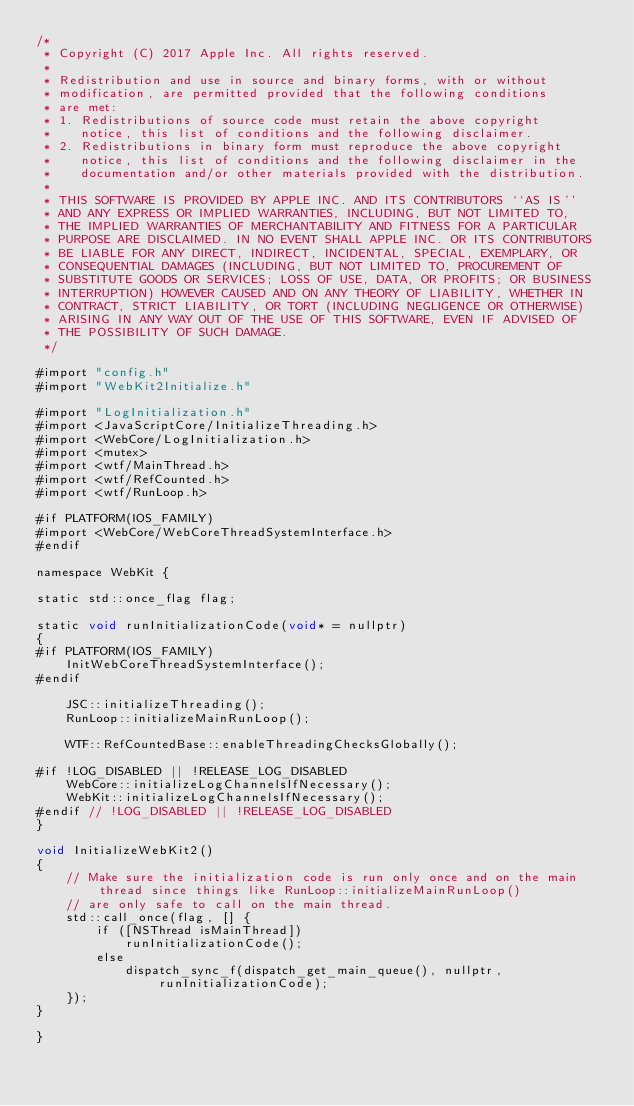Convert code to text. <code><loc_0><loc_0><loc_500><loc_500><_ObjectiveC_>/*
 * Copyright (C) 2017 Apple Inc. All rights reserved.
 *
 * Redistribution and use in source and binary forms, with or without
 * modification, are permitted provided that the following conditions
 * are met:
 * 1. Redistributions of source code must retain the above copyright
 *    notice, this list of conditions and the following disclaimer.
 * 2. Redistributions in binary form must reproduce the above copyright
 *    notice, this list of conditions and the following disclaimer in the
 *    documentation and/or other materials provided with the distribution.
 *
 * THIS SOFTWARE IS PROVIDED BY APPLE INC. AND ITS CONTRIBUTORS ``AS IS''
 * AND ANY EXPRESS OR IMPLIED WARRANTIES, INCLUDING, BUT NOT LIMITED TO,
 * THE IMPLIED WARRANTIES OF MERCHANTABILITY AND FITNESS FOR A PARTICULAR
 * PURPOSE ARE DISCLAIMED. IN NO EVENT SHALL APPLE INC. OR ITS CONTRIBUTORS
 * BE LIABLE FOR ANY DIRECT, INDIRECT, INCIDENTAL, SPECIAL, EXEMPLARY, OR
 * CONSEQUENTIAL DAMAGES (INCLUDING, BUT NOT LIMITED TO, PROCUREMENT OF
 * SUBSTITUTE GOODS OR SERVICES; LOSS OF USE, DATA, OR PROFITS; OR BUSINESS
 * INTERRUPTION) HOWEVER CAUSED AND ON ANY THEORY OF LIABILITY, WHETHER IN
 * CONTRACT, STRICT LIABILITY, OR TORT (INCLUDING NEGLIGENCE OR OTHERWISE)
 * ARISING IN ANY WAY OUT OF THE USE OF THIS SOFTWARE, EVEN IF ADVISED OF
 * THE POSSIBILITY OF SUCH DAMAGE.
 */

#import "config.h"
#import "WebKit2Initialize.h"

#import "LogInitialization.h"
#import <JavaScriptCore/InitializeThreading.h>
#import <WebCore/LogInitialization.h>
#import <mutex>
#import <wtf/MainThread.h>
#import <wtf/RefCounted.h>
#import <wtf/RunLoop.h>

#if PLATFORM(IOS_FAMILY)
#import <WebCore/WebCoreThreadSystemInterface.h>
#endif

namespace WebKit {

static std::once_flag flag;

static void runInitializationCode(void* = nullptr)
{
#if PLATFORM(IOS_FAMILY)
    InitWebCoreThreadSystemInterface();
#endif

    JSC::initializeThreading();
    RunLoop::initializeMainRunLoop();

    WTF::RefCountedBase::enableThreadingChecksGlobally();

#if !LOG_DISABLED || !RELEASE_LOG_DISABLED
    WebCore::initializeLogChannelsIfNecessary();
    WebKit::initializeLogChannelsIfNecessary();
#endif // !LOG_DISABLED || !RELEASE_LOG_DISABLED
}

void InitializeWebKit2()
{
    // Make sure the initialization code is run only once and on the main thread since things like RunLoop::initializeMainRunLoop()
    // are only safe to call on the main thread.
    std::call_once(flag, [] {
        if ([NSThread isMainThread])
            runInitializationCode();
        else
            dispatch_sync_f(dispatch_get_main_queue(), nullptr, runInitializationCode);
    });
}

}
</code> 